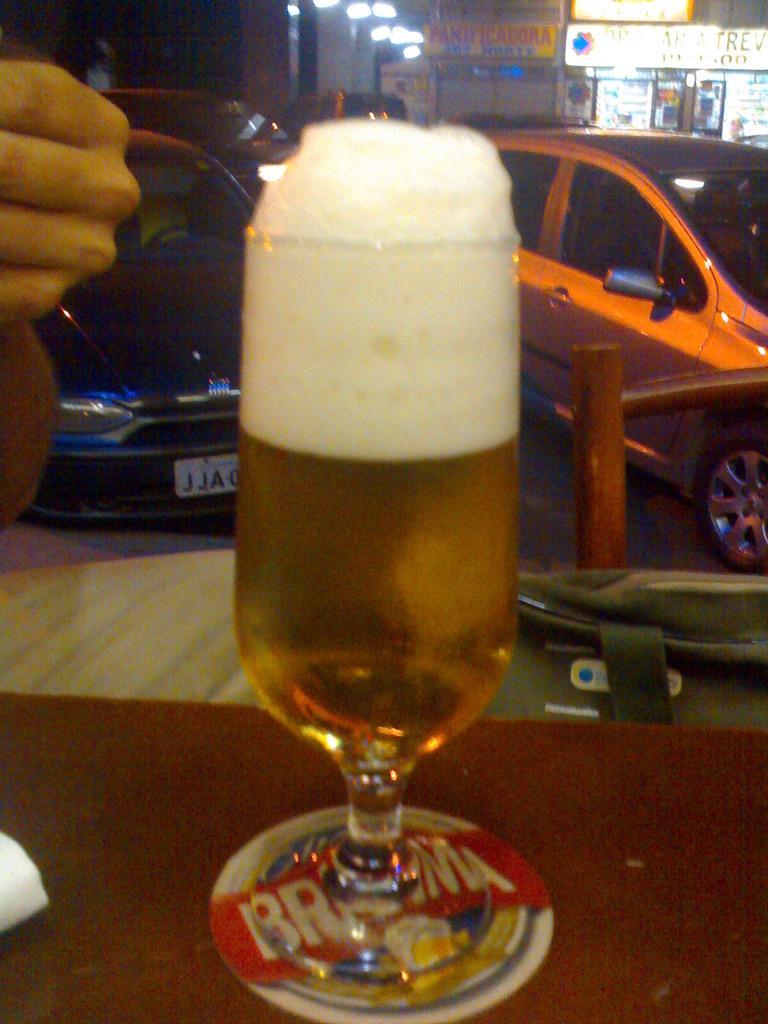In one or two sentences, can you explain what this image depicts? In this image, we can see a wine glass with liquid is placed on the surface. Background we can see few vehicles, stalls, hoardings, lights. Left side of the image, we can see a human hand and some white color object. 